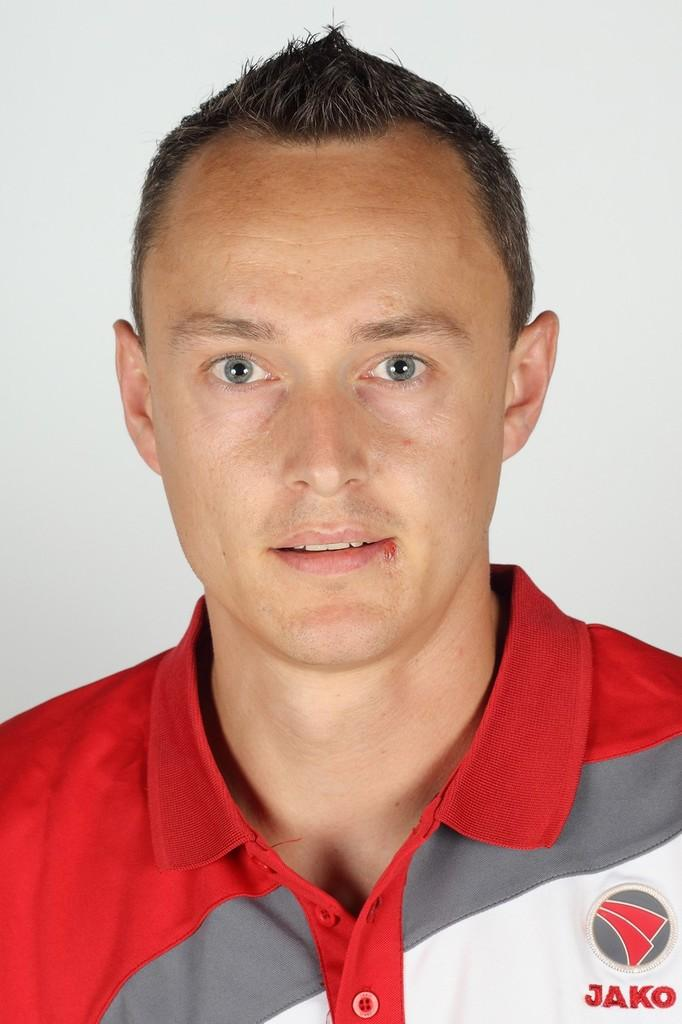Provide a one-sentence caption for the provided image. Jako reads the patch sewn onto the front of this shirt. 